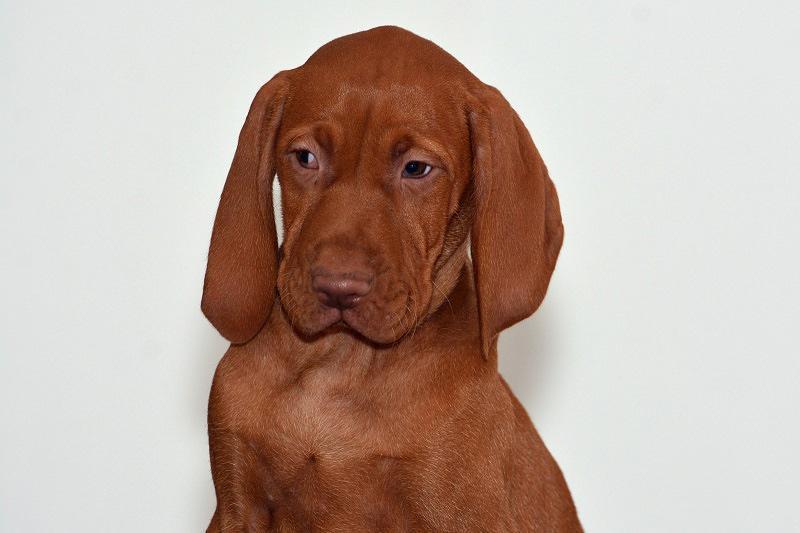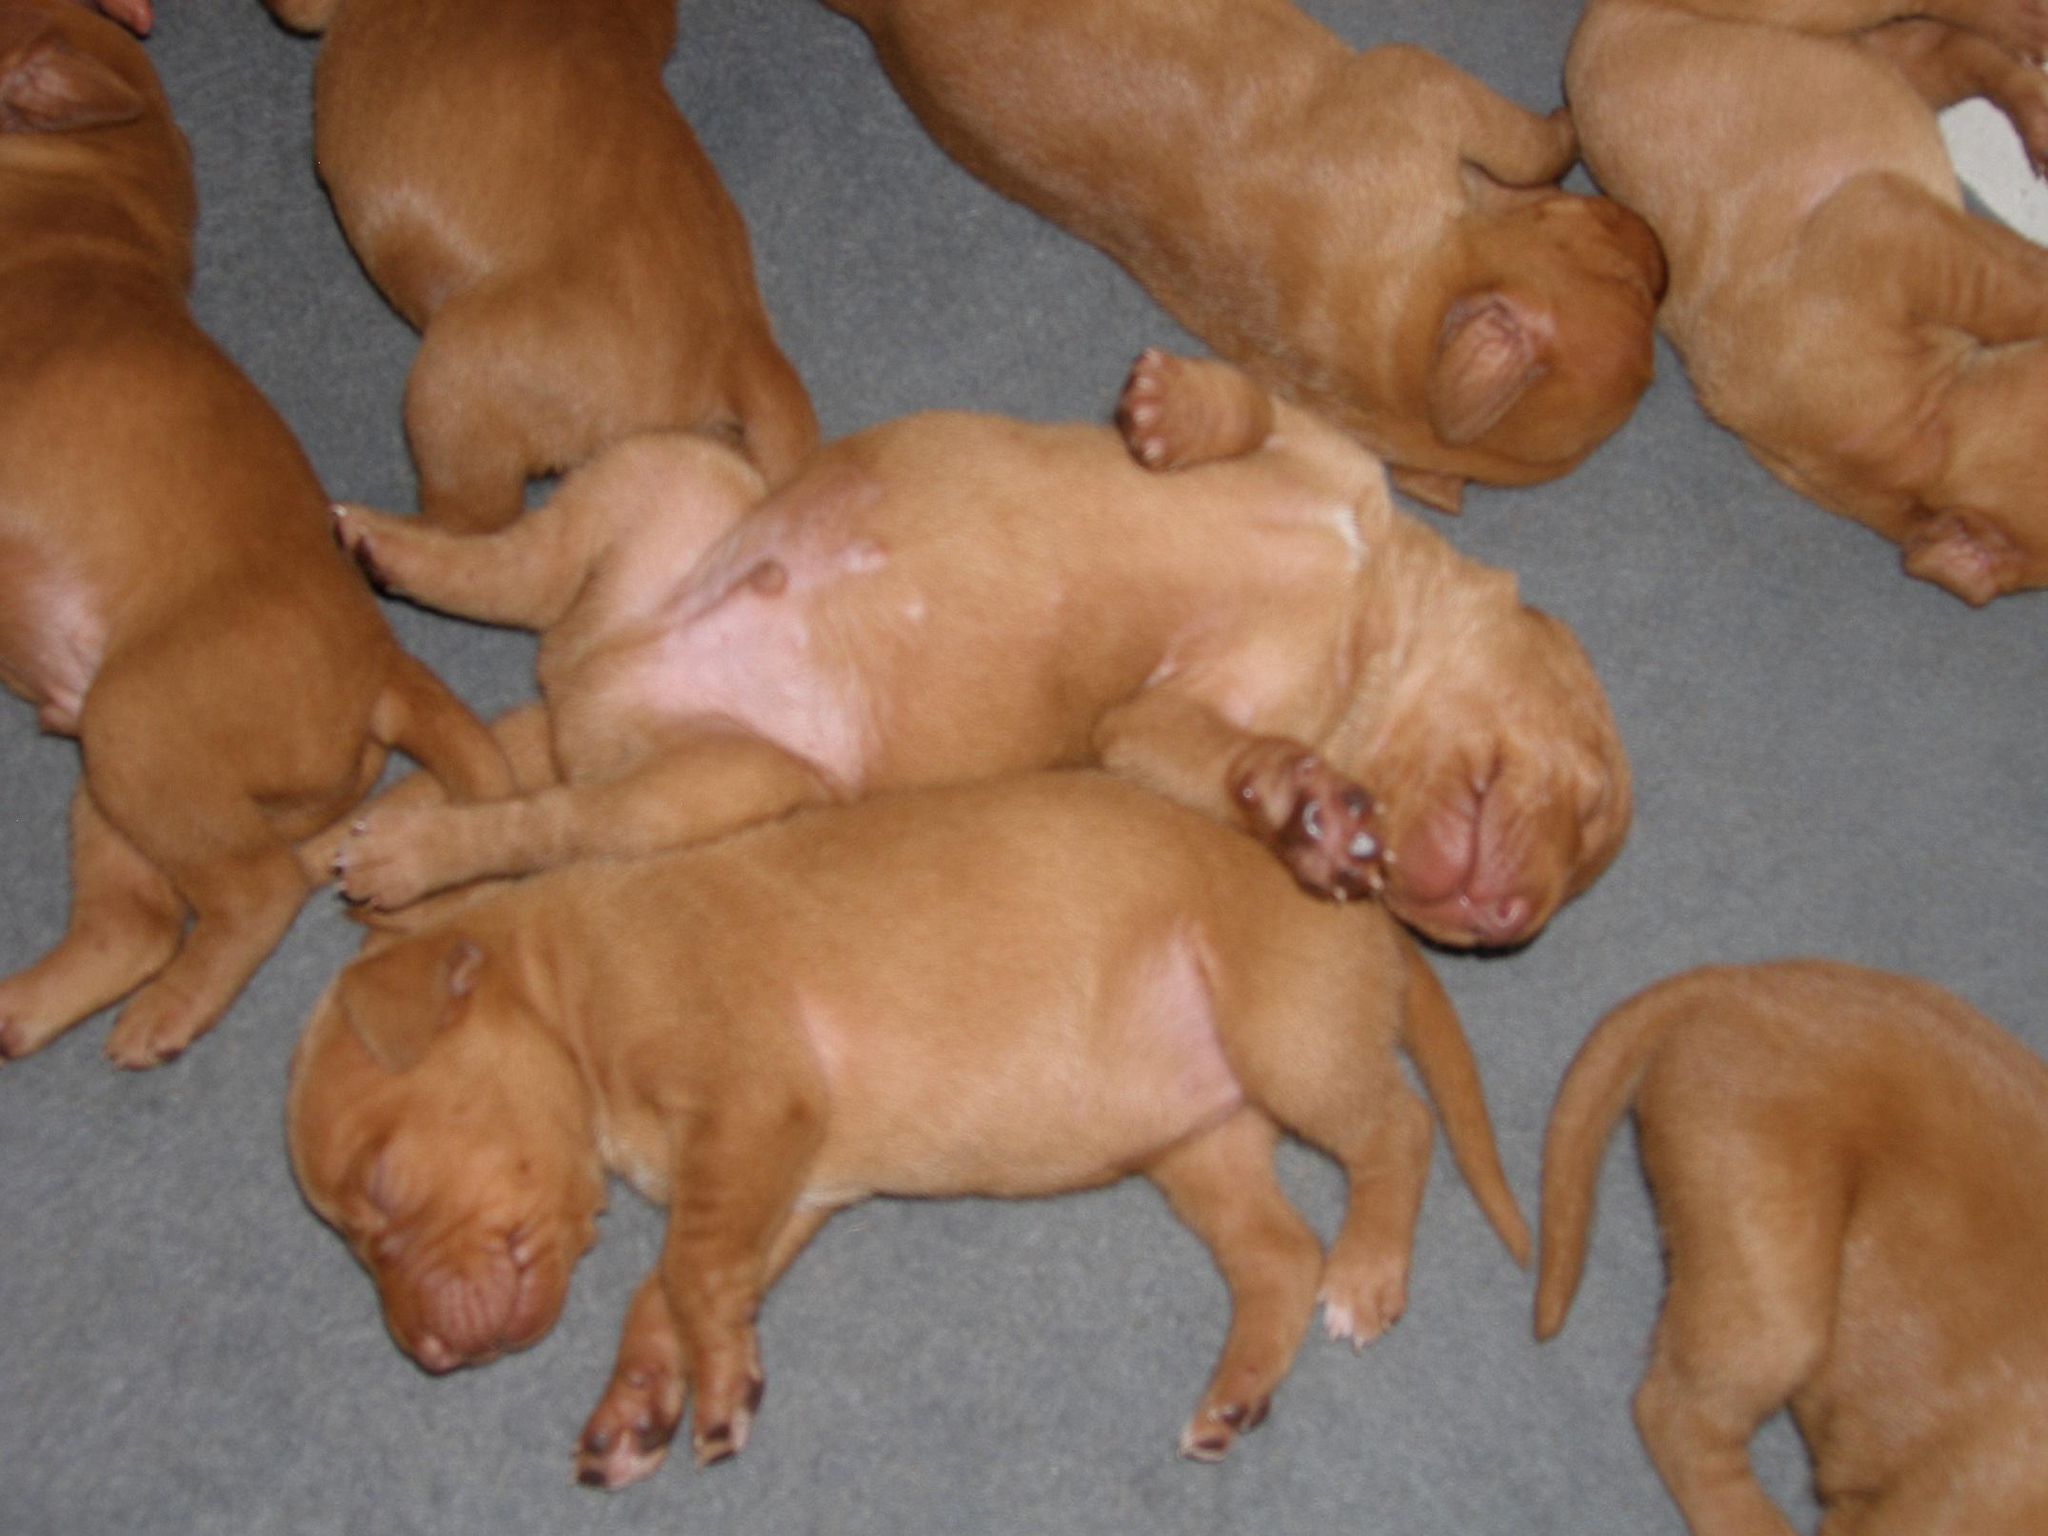The first image is the image on the left, the second image is the image on the right. For the images displayed, is the sentence "There are no more than two dogs." factually correct? Answer yes or no. No. The first image is the image on the left, the second image is the image on the right. Considering the images on both sides, is "An image shows exactly one dog reclining on a soft piece of furniture, with its rear to the right and its head to the left." valid? Answer yes or no. No. 